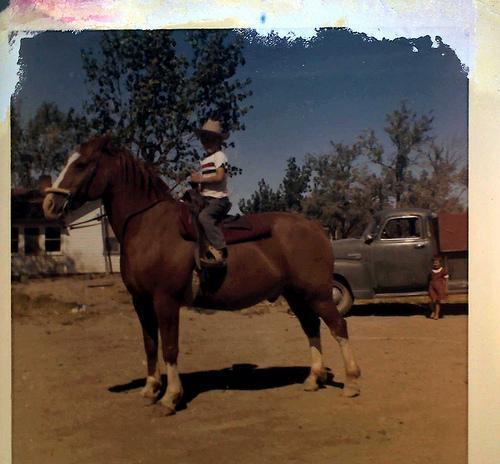How many children are sitting on a horse?
Give a very brief answer. 1. How many horses are there?
Give a very brief answer. 1. How many people with white shirts on are on the horse?
Give a very brief answer. 1. 